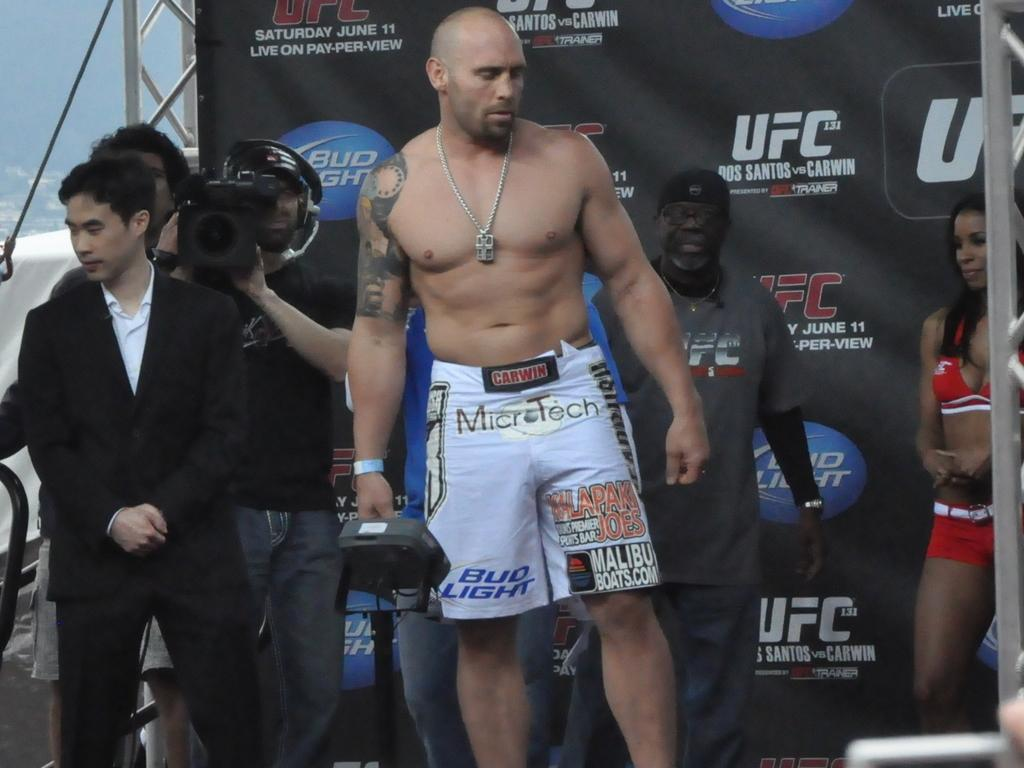<image>
Present a compact description of the photo's key features. Man wearing boxing shorts which say Bud Light on it. 